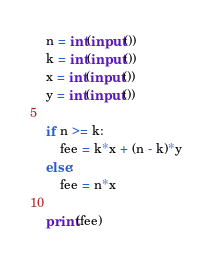<code> <loc_0><loc_0><loc_500><loc_500><_Python_>n = int(input())
k = int(input())
x = int(input())
y = int(input())

if n >= k:
    fee = k*x + (n - k)*y
else:
    fee = n*x

print(fee)</code> 